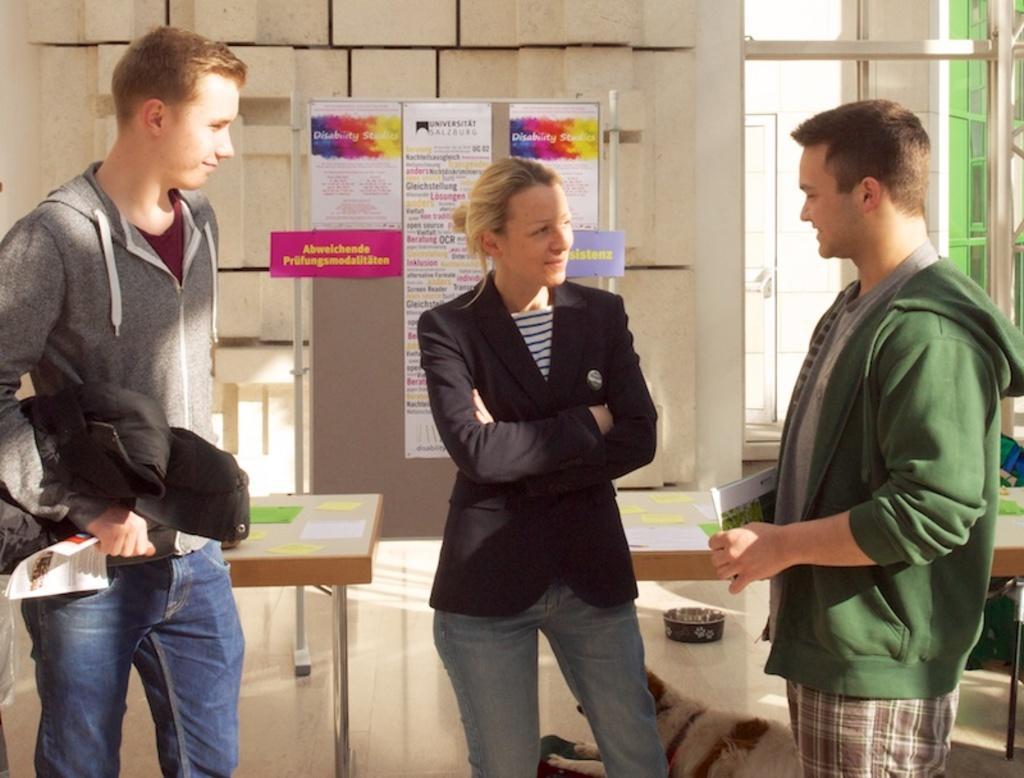How would you summarize this image in a sentence or two? On the left side of the image we can see a person is standing and holding a book in his hands. In the middle of the image we can see a lady is standing. On the right side of the image we can see a person is standing and holding a book in his hands. 